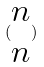<formula> <loc_0><loc_0><loc_500><loc_500>( \begin{matrix} n \\ n \end{matrix} )</formula> 